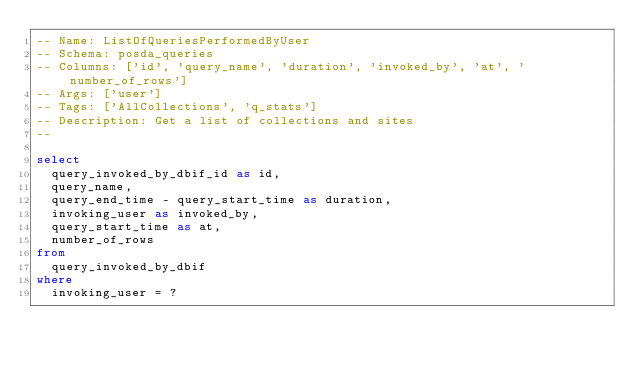<code> <loc_0><loc_0><loc_500><loc_500><_SQL_>-- Name: ListOfQueriesPerformedByUser
-- Schema: posda_queries
-- Columns: ['id', 'query_name', 'duration', 'invoked_by', 'at', 'number_of_rows']
-- Args: ['user']
-- Tags: ['AllCollections', 'q_stats']
-- Description: Get a list of collections and sites
-- 

select
  query_invoked_by_dbif_id as id,
  query_name,
  query_end_time - query_start_time as duration,
  invoking_user as invoked_by,
  query_start_time as at, 
  number_of_rows
from
  query_invoked_by_dbif
where
  invoking_user = ?</code> 